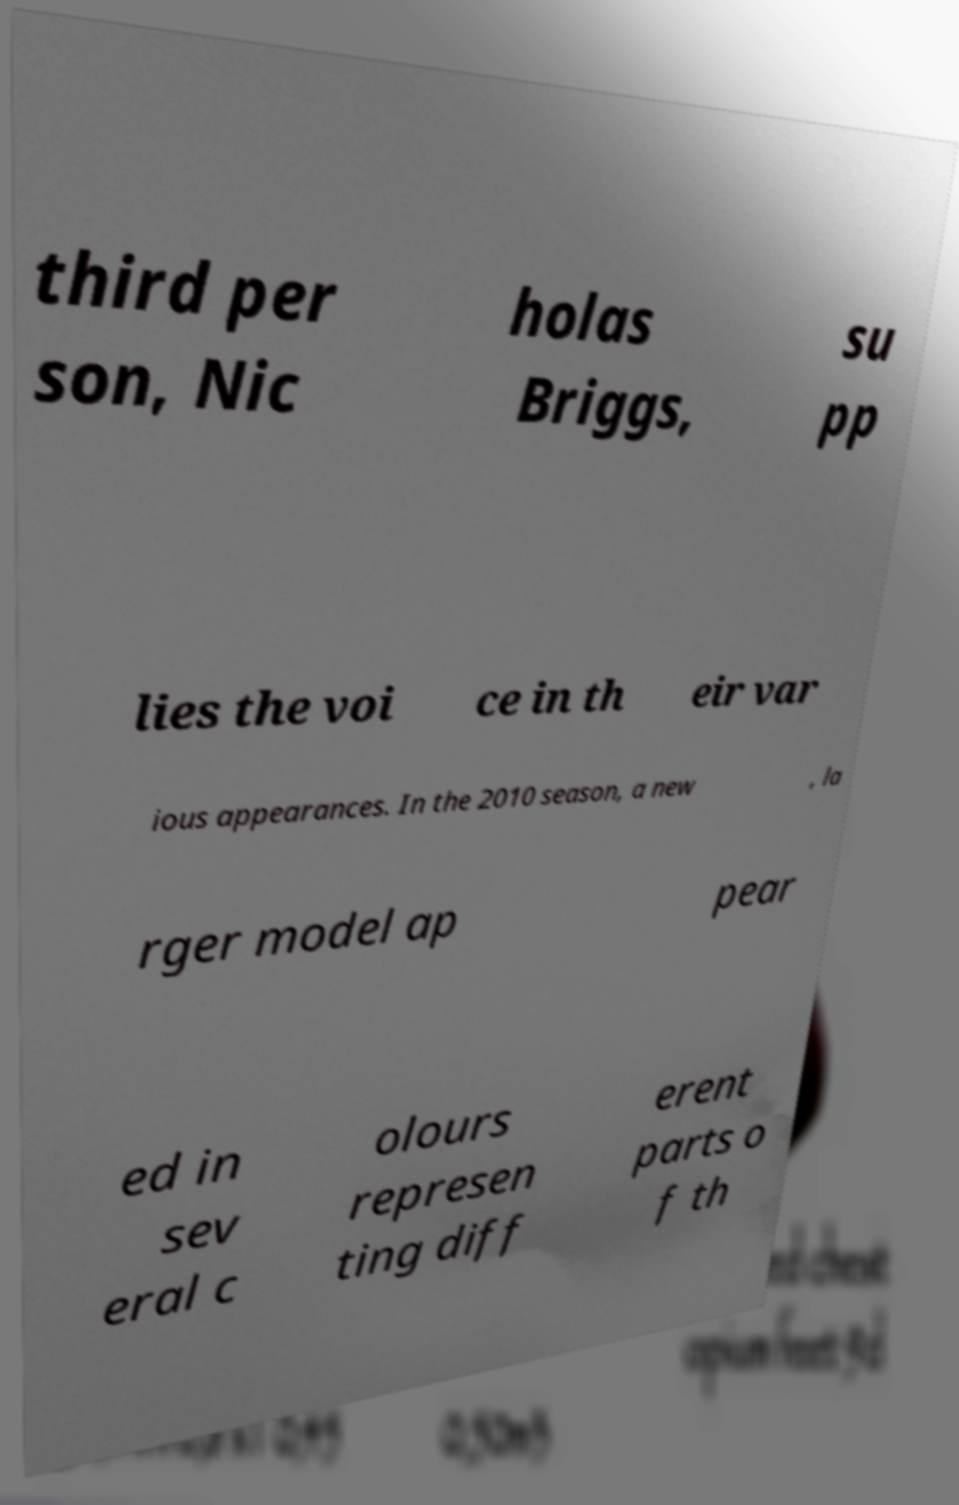Can you accurately transcribe the text from the provided image for me? third per son, Nic holas Briggs, su pp lies the voi ce in th eir var ious appearances. In the 2010 season, a new , la rger model ap pear ed in sev eral c olours represen ting diff erent parts o f th 